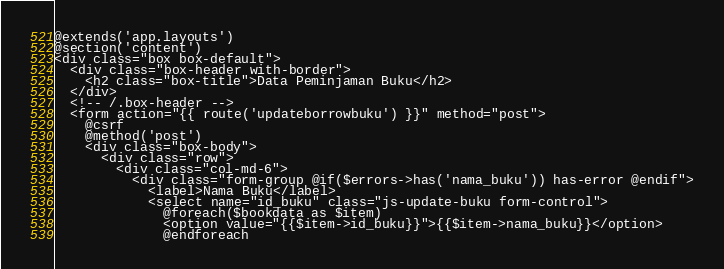<code> <loc_0><loc_0><loc_500><loc_500><_PHP_>@extends('app.layouts')
@section('content')
<div class="box box-default">
  <div class="box-header with-border">
    <h2 class="box-title">Data Peminjaman Buku</h2>
  </div>
  <!-- /.box-header -->
  <form action="{{ route('updateborrowbuku') }}" method="post">
    @csrf
    @method('post')
    <div class="box-body">
      <div class="row">
        <div class="col-md-6">
          <div class="form-group @if($errors->has('nama_buku')) has-error @endif">
            <label>Nama Buku</label>
            <select name="id_buku" class="js-update-buku form-control">
              @foreach($bookdata as $item)
              <option value="{{$item->id_buku}}">{{$item->nama_buku}}</option>
              @endforeach</code> 